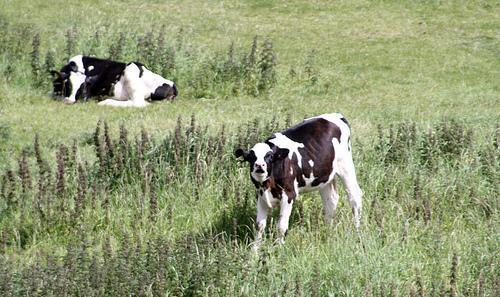How many cows are there?
Give a very brief answer. 2. 